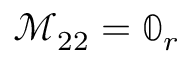Convert formula to latex. <formula><loc_0><loc_0><loc_500><loc_500>\mathcal { M } _ { 2 2 } = \mathbb { 0 } _ { r }</formula> 